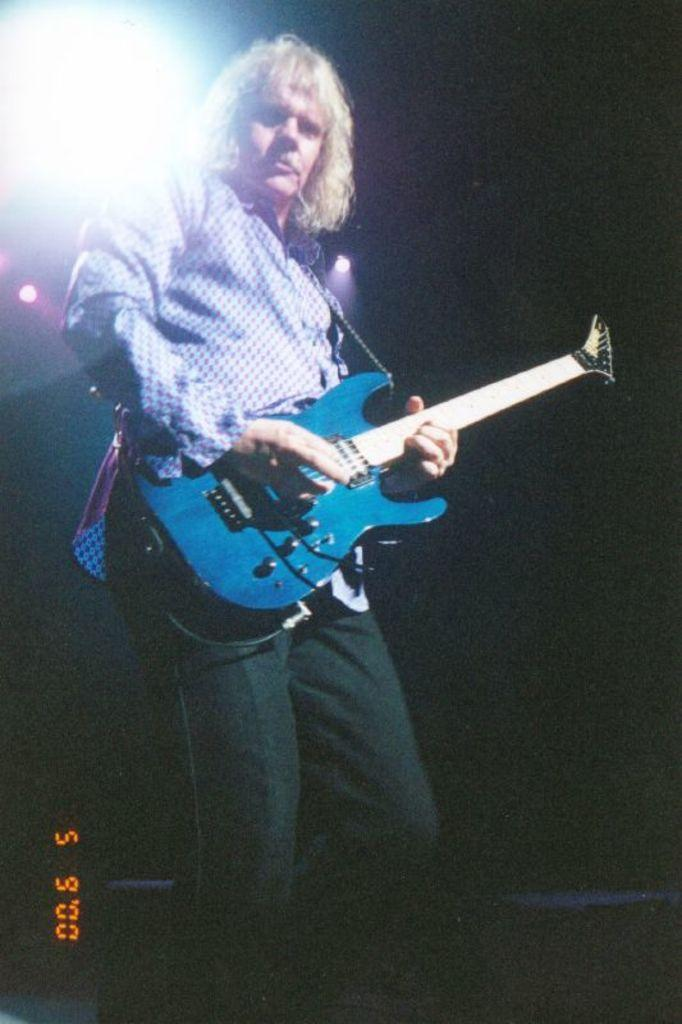What is the main subject of the image? There is a man in the image. What is the man doing in the image? The man is standing and playing a guitar. Is there any text or number visible in the image? Yes, there is a number displayed on the left at the bottom of the image. How many children are waving good-bye to the man in the image? There are no children present in the image, nor is anyone waving good-bye. What song is the man playing on his guitar in the image? The image does not provide information about the specific song the man is playing on his guitar. 